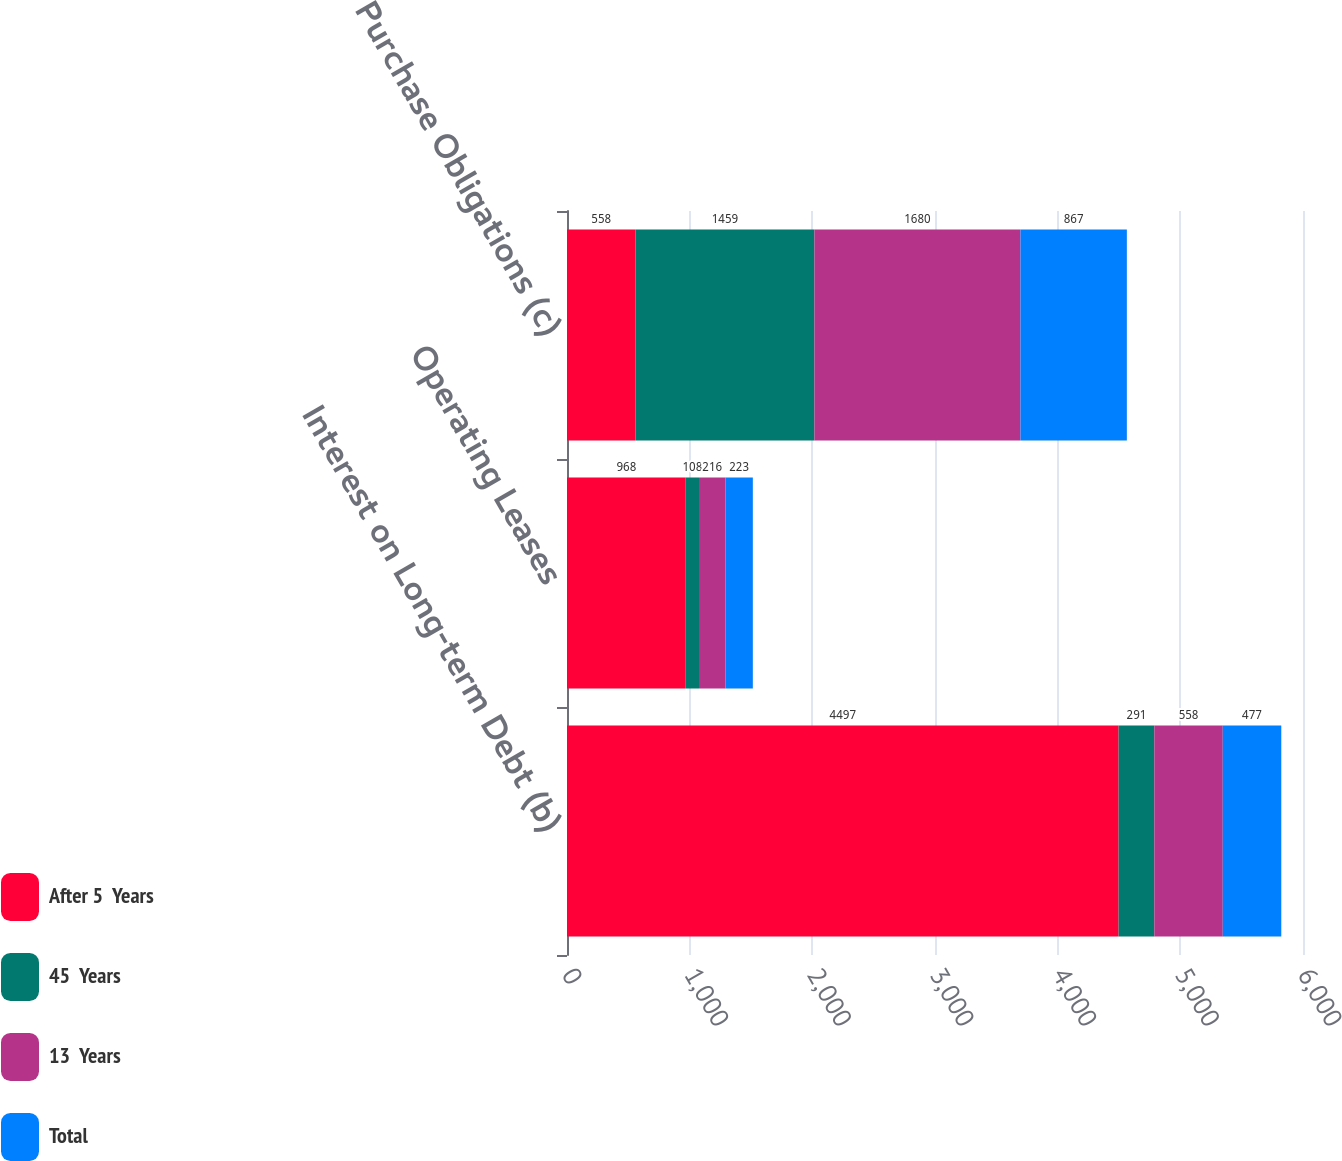Convert chart. <chart><loc_0><loc_0><loc_500><loc_500><stacked_bar_chart><ecel><fcel>Interest on Long-term Debt (b)<fcel>Operating Leases<fcel>Purchase Obligations (c)<nl><fcel>After 5  Years<fcel>4497<fcel>968<fcel>558<nl><fcel>45  Years<fcel>291<fcel>108<fcel>1459<nl><fcel>13  Years<fcel>558<fcel>216<fcel>1680<nl><fcel>Total<fcel>477<fcel>223<fcel>867<nl></chart> 